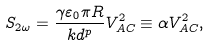Convert formula to latex. <formula><loc_0><loc_0><loc_500><loc_500>S _ { 2 \omega } = \frac { \gamma \varepsilon _ { 0 } \pi R } { k d ^ { p } } V _ { A C } ^ { 2 } \equiv \alpha V _ { A C } ^ { 2 } ,</formula> 